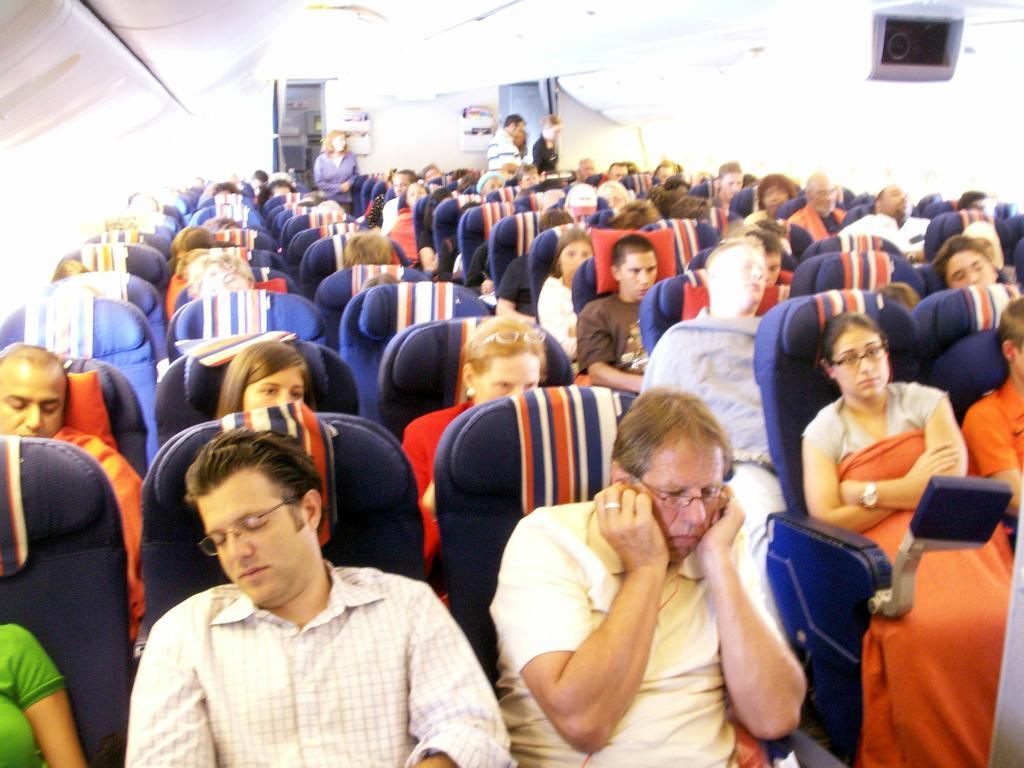How would you summarize this image in a sentence or two? In this picture there are few persons sitting in chairs and there are four persons standing in the background and there is an object in the right top corner. 